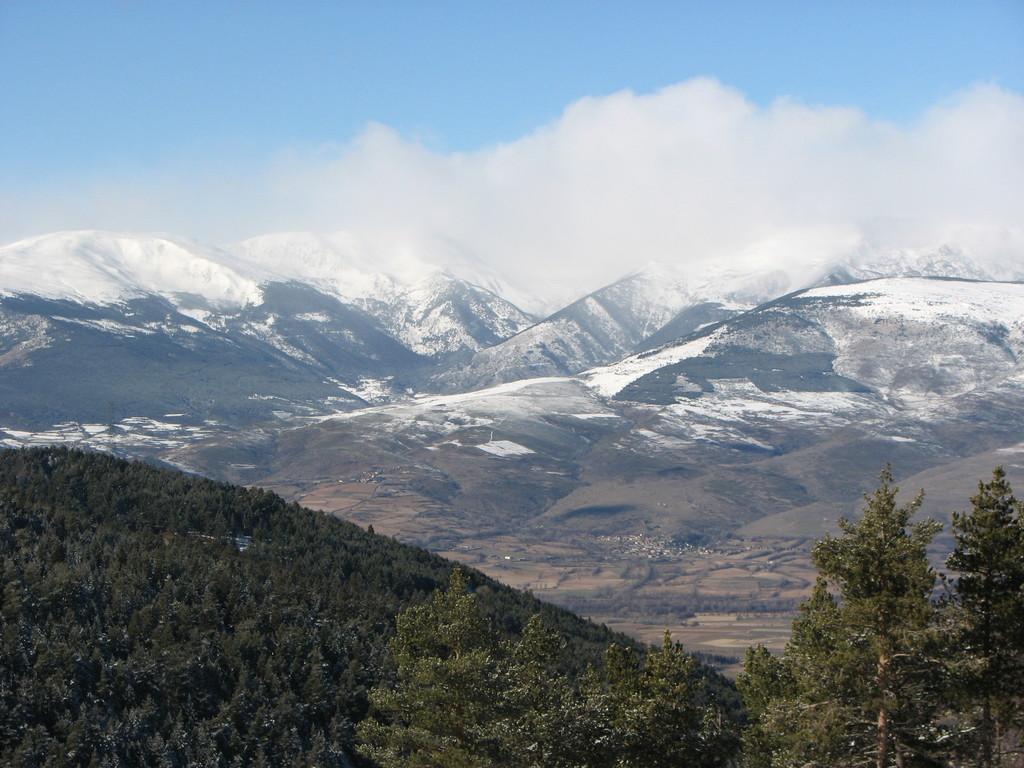In one or two sentences, can you explain what this image depicts? In the foreground of the picture I can see the trees. In the background, I can see the mountains. There are clouds in the sky. 